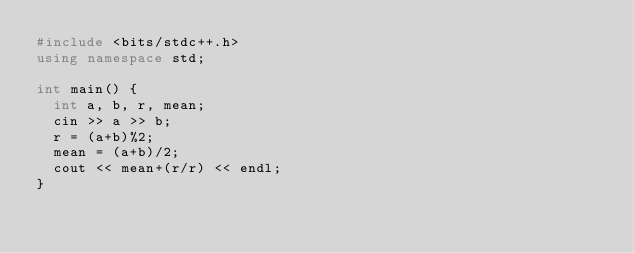Convert code to text. <code><loc_0><loc_0><loc_500><loc_500><_C++_>#include <bits/stdc++.h>
using namespace std;
 
int main() {
  int a, b, r, mean;
  cin >> a >> b;
  r = (a+b)%2;
  mean = (a+b)/2;
  cout << mean+(r/r) << endl;
}</code> 